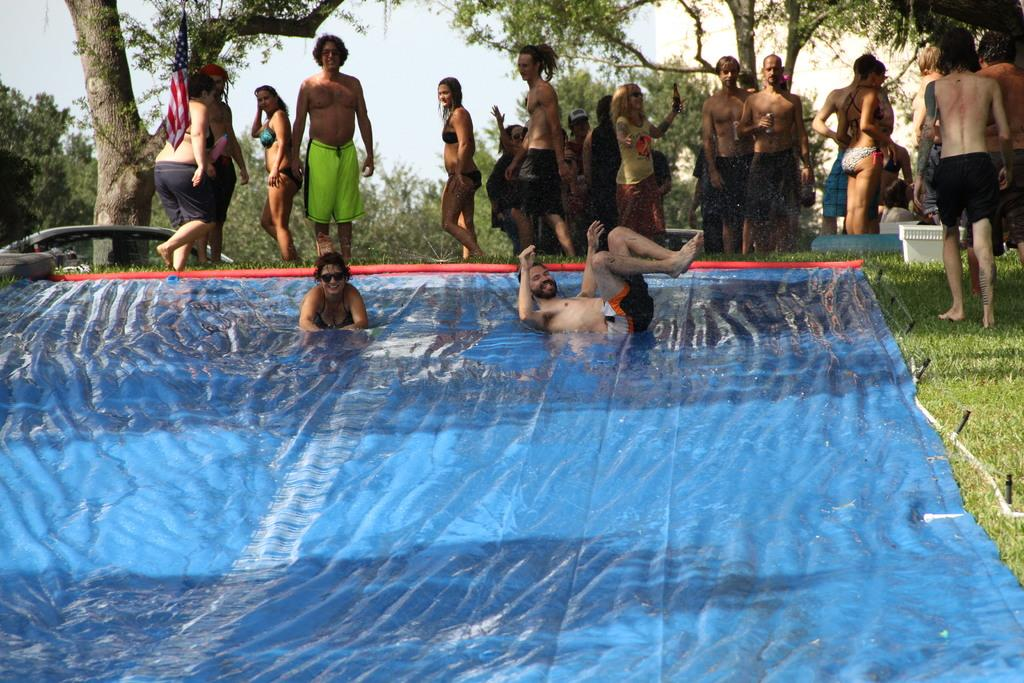What is located in the front of the image? There are people, a blue sheer, water, grass, and objects in the front of the image. Can you describe the people in the image? The people are in the front of the image, but their specific actions or appearances are not mentioned in the provided facts. What type of vegetation is visible in the front of the image? Grass is visible in the front of the image. What is visible in the background of the image? There are trees and sky visible in the background of the image. What is the reaction of the bears to the blue sheer in the image? There are no bears present in the image, so their reaction cannot be determined. How does the disgust factor of the objects in the front of the image compare to the disgust factor of the trees in the background? The provided facts do not mention any level of disgust associated with the objects or trees, so this comparison cannot be made. 